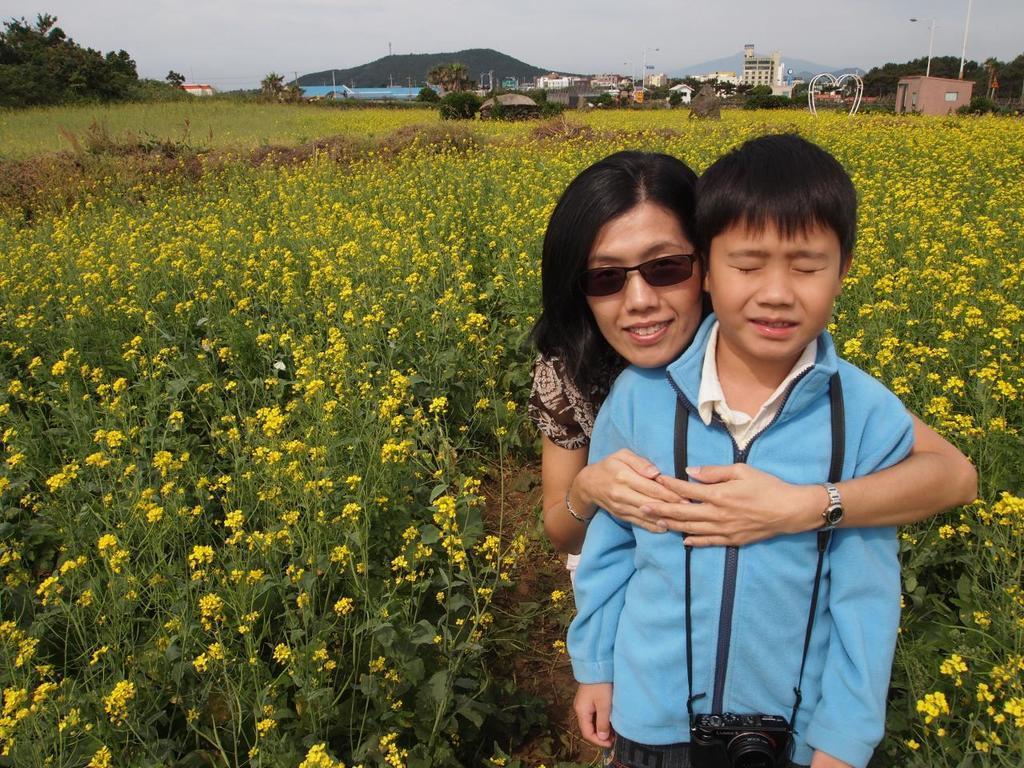Describe this image in one or two sentences. In this image I can see two persons standing, the person in front wearing blue color shirt and a camera and the other person is wearing brown color dress. I can also see few flowers in yellow color, background I can see trees in green color, few buildings, and sky in white color. 